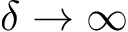<formula> <loc_0><loc_0><loc_500><loc_500>\delta \rightarrow \infty</formula> 